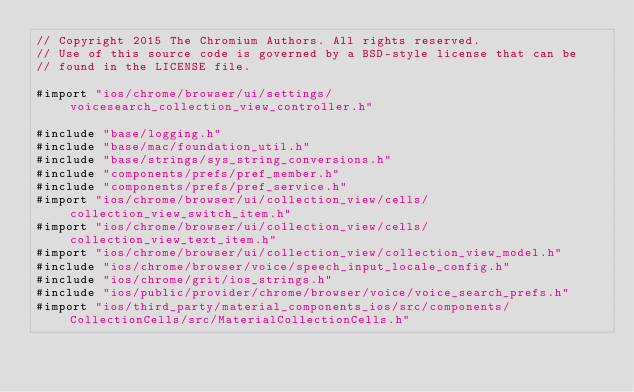Convert code to text. <code><loc_0><loc_0><loc_500><loc_500><_ObjectiveC_>// Copyright 2015 The Chromium Authors. All rights reserved.
// Use of this source code is governed by a BSD-style license that can be
// found in the LICENSE file.

#import "ios/chrome/browser/ui/settings/voicesearch_collection_view_controller.h"

#include "base/logging.h"
#include "base/mac/foundation_util.h"
#include "base/strings/sys_string_conversions.h"
#include "components/prefs/pref_member.h"
#include "components/prefs/pref_service.h"
#import "ios/chrome/browser/ui/collection_view/cells/collection_view_switch_item.h"
#import "ios/chrome/browser/ui/collection_view/cells/collection_view_text_item.h"
#import "ios/chrome/browser/ui/collection_view/collection_view_model.h"
#include "ios/chrome/browser/voice/speech_input_locale_config.h"
#include "ios/chrome/grit/ios_strings.h"
#include "ios/public/provider/chrome/browser/voice/voice_search_prefs.h"
#import "ios/third_party/material_components_ios/src/components/CollectionCells/src/MaterialCollectionCells.h"</code> 